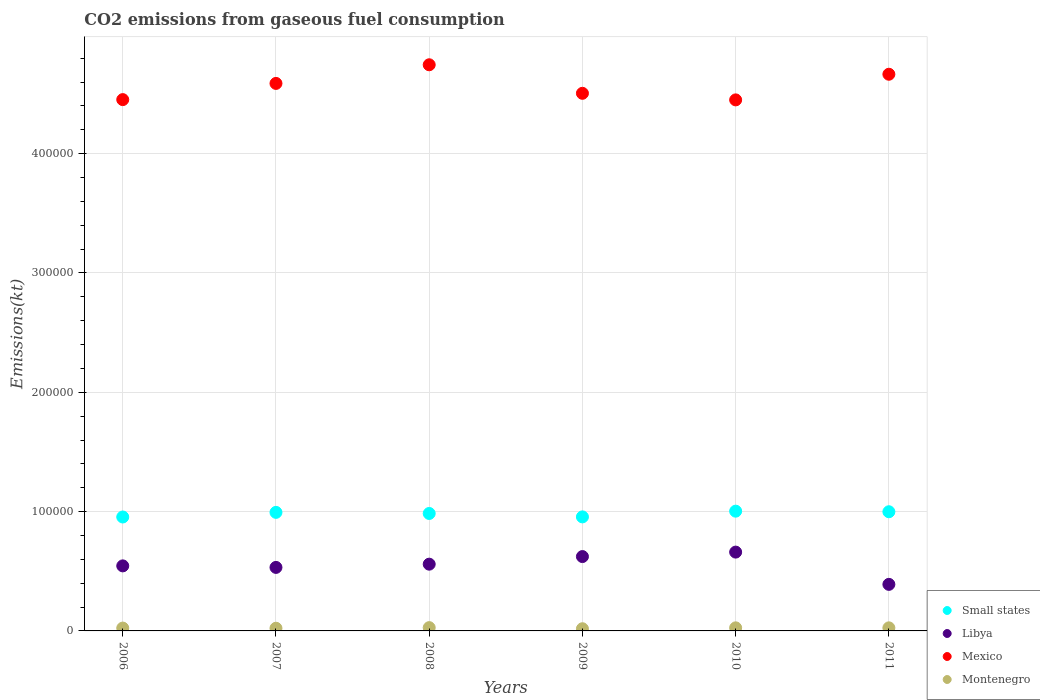How many different coloured dotlines are there?
Ensure brevity in your answer.  4. Is the number of dotlines equal to the number of legend labels?
Ensure brevity in your answer.  Yes. What is the amount of CO2 emitted in Montenegro in 2011?
Your answer should be very brief. 2570.57. Across all years, what is the maximum amount of CO2 emitted in Mexico?
Make the answer very short. 4.74e+05. Across all years, what is the minimum amount of CO2 emitted in Mexico?
Give a very brief answer. 4.45e+05. In which year was the amount of CO2 emitted in Mexico maximum?
Keep it short and to the point. 2008. In which year was the amount of CO2 emitted in Montenegro minimum?
Offer a terse response. 2009. What is the total amount of CO2 emitted in Libya in the graph?
Provide a succinct answer. 3.31e+05. What is the difference between the amount of CO2 emitted in Mexico in 2009 and that in 2011?
Your answer should be very brief. -1.60e+04. What is the difference between the amount of CO2 emitted in Small states in 2006 and the amount of CO2 emitted in Montenegro in 2008?
Offer a very short reply. 9.27e+04. What is the average amount of CO2 emitted in Mexico per year?
Your response must be concise. 4.57e+05. In the year 2007, what is the difference between the amount of CO2 emitted in Small states and amount of CO2 emitted in Libya?
Give a very brief answer. 4.61e+04. What is the ratio of the amount of CO2 emitted in Libya in 2007 to that in 2009?
Your response must be concise. 0.85. Is the amount of CO2 emitted in Mexico in 2008 less than that in 2009?
Keep it short and to the point. No. Is the difference between the amount of CO2 emitted in Small states in 2007 and 2008 greater than the difference between the amount of CO2 emitted in Libya in 2007 and 2008?
Your answer should be very brief. Yes. What is the difference between the highest and the second highest amount of CO2 emitted in Libya?
Offer a terse response. 3740.34. What is the difference between the highest and the lowest amount of CO2 emitted in Small states?
Provide a short and direct response. 4882.64. Is the sum of the amount of CO2 emitted in Small states in 2009 and 2010 greater than the maximum amount of CO2 emitted in Libya across all years?
Provide a succinct answer. Yes. Does the amount of CO2 emitted in Mexico monotonically increase over the years?
Your response must be concise. No. Is the amount of CO2 emitted in Montenegro strictly greater than the amount of CO2 emitted in Libya over the years?
Give a very brief answer. No. Is the amount of CO2 emitted in Small states strictly less than the amount of CO2 emitted in Mexico over the years?
Keep it short and to the point. Yes. How many dotlines are there?
Keep it short and to the point. 4. How many years are there in the graph?
Offer a very short reply. 6. Are the values on the major ticks of Y-axis written in scientific E-notation?
Your answer should be very brief. No. Does the graph contain any zero values?
Your answer should be very brief. No. Does the graph contain grids?
Provide a succinct answer. Yes. How many legend labels are there?
Make the answer very short. 4. How are the legend labels stacked?
Provide a succinct answer. Vertical. What is the title of the graph?
Offer a terse response. CO2 emissions from gaseous fuel consumption. What is the label or title of the Y-axis?
Provide a succinct answer. Emissions(kt). What is the Emissions(kt) in Small states in 2006?
Give a very brief answer. 9.55e+04. What is the Emissions(kt) of Libya in 2006?
Your answer should be compact. 5.45e+04. What is the Emissions(kt) of Mexico in 2006?
Ensure brevity in your answer.  4.45e+05. What is the Emissions(kt) in Montenegro in 2006?
Offer a terse response. 2383.55. What is the Emissions(kt) in Small states in 2007?
Your answer should be compact. 9.94e+04. What is the Emissions(kt) of Libya in 2007?
Keep it short and to the point. 5.32e+04. What is the Emissions(kt) in Mexico in 2007?
Your response must be concise. 4.59e+05. What is the Emissions(kt) of Montenegro in 2007?
Provide a short and direct response. 2251.54. What is the Emissions(kt) in Small states in 2008?
Provide a short and direct response. 9.84e+04. What is the Emissions(kt) of Libya in 2008?
Make the answer very short. 5.59e+04. What is the Emissions(kt) of Mexico in 2008?
Make the answer very short. 4.74e+05. What is the Emissions(kt) in Montenegro in 2008?
Provide a short and direct response. 2750.25. What is the Emissions(kt) of Small states in 2009?
Provide a short and direct response. 9.56e+04. What is the Emissions(kt) of Libya in 2009?
Your answer should be compact. 6.23e+04. What is the Emissions(kt) in Mexico in 2009?
Your response must be concise. 4.51e+05. What is the Emissions(kt) of Montenegro in 2009?
Offer a very short reply. 1826.17. What is the Emissions(kt) in Small states in 2010?
Offer a very short reply. 1.00e+05. What is the Emissions(kt) of Libya in 2010?
Offer a terse response. 6.61e+04. What is the Emissions(kt) of Mexico in 2010?
Provide a short and direct response. 4.45e+05. What is the Emissions(kt) of Montenegro in 2010?
Your response must be concise. 2581.57. What is the Emissions(kt) of Small states in 2011?
Provide a succinct answer. 9.99e+04. What is the Emissions(kt) in Libya in 2011?
Keep it short and to the point. 3.90e+04. What is the Emissions(kt) in Mexico in 2011?
Keep it short and to the point. 4.67e+05. What is the Emissions(kt) of Montenegro in 2011?
Offer a very short reply. 2570.57. Across all years, what is the maximum Emissions(kt) of Small states?
Give a very brief answer. 1.00e+05. Across all years, what is the maximum Emissions(kt) of Libya?
Make the answer very short. 6.61e+04. Across all years, what is the maximum Emissions(kt) of Mexico?
Offer a terse response. 4.74e+05. Across all years, what is the maximum Emissions(kt) in Montenegro?
Keep it short and to the point. 2750.25. Across all years, what is the minimum Emissions(kt) in Small states?
Your response must be concise. 9.55e+04. Across all years, what is the minimum Emissions(kt) of Libya?
Your answer should be compact. 3.90e+04. Across all years, what is the minimum Emissions(kt) of Mexico?
Provide a succinct answer. 4.45e+05. Across all years, what is the minimum Emissions(kt) in Montenegro?
Offer a terse response. 1826.17. What is the total Emissions(kt) of Small states in the graph?
Provide a short and direct response. 5.89e+05. What is the total Emissions(kt) in Libya in the graph?
Keep it short and to the point. 3.31e+05. What is the total Emissions(kt) in Mexico in the graph?
Your answer should be compact. 2.74e+06. What is the total Emissions(kt) in Montenegro in the graph?
Give a very brief answer. 1.44e+04. What is the difference between the Emissions(kt) of Small states in 2006 and that in 2007?
Give a very brief answer. -3870.17. What is the difference between the Emissions(kt) of Libya in 2006 and that in 2007?
Make the answer very short. 1279.78. What is the difference between the Emissions(kt) of Mexico in 2006 and that in 2007?
Provide a succinct answer. -1.36e+04. What is the difference between the Emissions(kt) in Montenegro in 2006 and that in 2007?
Give a very brief answer. 132.01. What is the difference between the Emissions(kt) of Small states in 2006 and that in 2008?
Your response must be concise. -2949.4. What is the difference between the Emissions(kt) of Libya in 2006 and that in 2008?
Keep it short and to the point. -1433.8. What is the difference between the Emissions(kt) in Mexico in 2006 and that in 2008?
Your answer should be compact. -2.92e+04. What is the difference between the Emissions(kt) in Montenegro in 2006 and that in 2008?
Give a very brief answer. -366.7. What is the difference between the Emissions(kt) of Small states in 2006 and that in 2009?
Provide a short and direct response. -88.04. What is the difference between the Emissions(kt) of Libya in 2006 and that in 2009?
Keep it short and to the point. -7807.04. What is the difference between the Emissions(kt) of Mexico in 2006 and that in 2009?
Your answer should be compact. -5284.15. What is the difference between the Emissions(kt) in Montenegro in 2006 and that in 2009?
Make the answer very short. 557.38. What is the difference between the Emissions(kt) in Small states in 2006 and that in 2010?
Your answer should be compact. -4882.64. What is the difference between the Emissions(kt) of Libya in 2006 and that in 2010?
Provide a succinct answer. -1.15e+04. What is the difference between the Emissions(kt) in Mexico in 2006 and that in 2010?
Provide a succinct answer. 227.35. What is the difference between the Emissions(kt) in Montenegro in 2006 and that in 2010?
Offer a terse response. -198.02. What is the difference between the Emissions(kt) in Small states in 2006 and that in 2011?
Your response must be concise. -4398.42. What is the difference between the Emissions(kt) of Libya in 2006 and that in 2011?
Give a very brief answer. 1.55e+04. What is the difference between the Emissions(kt) of Mexico in 2006 and that in 2011?
Ensure brevity in your answer.  -2.13e+04. What is the difference between the Emissions(kt) in Montenegro in 2006 and that in 2011?
Ensure brevity in your answer.  -187.02. What is the difference between the Emissions(kt) in Small states in 2007 and that in 2008?
Offer a very short reply. 920.77. What is the difference between the Emissions(kt) in Libya in 2007 and that in 2008?
Ensure brevity in your answer.  -2713.58. What is the difference between the Emissions(kt) in Mexico in 2007 and that in 2008?
Your answer should be compact. -1.56e+04. What is the difference between the Emissions(kt) of Montenegro in 2007 and that in 2008?
Keep it short and to the point. -498.71. What is the difference between the Emissions(kt) in Small states in 2007 and that in 2009?
Give a very brief answer. 3782.12. What is the difference between the Emissions(kt) of Libya in 2007 and that in 2009?
Keep it short and to the point. -9086.83. What is the difference between the Emissions(kt) in Mexico in 2007 and that in 2009?
Ensure brevity in your answer.  8291.09. What is the difference between the Emissions(kt) of Montenegro in 2007 and that in 2009?
Your response must be concise. 425.37. What is the difference between the Emissions(kt) of Small states in 2007 and that in 2010?
Provide a short and direct response. -1012.48. What is the difference between the Emissions(kt) in Libya in 2007 and that in 2010?
Ensure brevity in your answer.  -1.28e+04. What is the difference between the Emissions(kt) of Mexico in 2007 and that in 2010?
Your answer should be compact. 1.38e+04. What is the difference between the Emissions(kt) of Montenegro in 2007 and that in 2010?
Provide a short and direct response. -330.03. What is the difference between the Emissions(kt) of Small states in 2007 and that in 2011?
Your answer should be very brief. -528.25. What is the difference between the Emissions(kt) in Libya in 2007 and that in 2011?
Make the answer very short. 1.42e+04. What is the difference between the Emissions(kt) of Mexico in 2007 and that in 2011?
Offer a very short reply. -7682.36. What is the difference between the Emissions(kt) in Montenegro in 2007 and that in 2011?
Provide a succinct answer. -319.03. What is the difference between the Emissions(kt) in Small states in 2008 and that in 2009?
Offer a terse response. 2861.35. What is the difference between the Emissions(kt) in Libya in 2008 and that in 2009?
Give a very brief answer. -6373.25. What is the difference between the Emissions(kt) of Mexico in 2008 and that in 2009?
Make the answer very short. 2.39e+04. What is the difference between the Emissions(kt) in Montenegro in 2008 and that in 2009?
Offer a very short reply. 924.08. What is the difference between the Emissions(kt) of Small states in 2008 and that in 2010?
Your response must be concise. -1933.25. What is the difference between the Emissions(kt) of Libya in 2008 and that in 2010?
Provide a short and direct response. -1.01e+04. What is the difference between the Emissions(kt) in Mexico in 2008 and that in 2010?
Ensure brevity in your answer.  2.94e+04. What is the difference between the Emissions(kt) in Montenegro in 2008 and that in 2010?
Offer a very short reply. 168.68. What is the difference between the Emissions(kt) in Small states in 2008 and that in 2011?
Keep it short and to the point. -1449.02. What is the difference between the Emissions(kt) in Libya in 2008 and that in 2011?
Make the answer very short. 1.69e+04. What is the difference between the Emissions(kt) of Mexico in 2008 and that in 2011?
Your response must be concise. 7942.72. What is the difference between the Emissions(kt) of Montenegro in 2008 and that in 2011?
Keep it short and to the point. 179.68. What is the difference between the Emissions(kt) of Small states in 2009 and that in 2010?
Offer a very short reply. -4794.6. What is the difference between the Emissions(kt) in Libya in 2009 and that in 2010?
Your answer should be compact. -3740.34. What is the difference between the Emissions(kt) in Mexico in 2009 and that in 2010?
Keep it short and to the point. 5511.5. What is the difference between the Emissions(kt) in Montenegro in 2009 and that in 2010?
Make the answer very short. -755.4. What is the difference between the Emissions(kt) of Small states in 2009 and that in 2011?
Your answer should be compact. -4310.37. What is the difference between the Emissions(kt) in Libya in 2009 and that in 2011?
Offer a terse response. 2.33e+04. What is the difference between the Emissions(kt) of Mexico in 2009 and that in 2011?
Your answer should be compact. -1.60e+04. What is the difference between the Emissions(kt) in Montenegro in 2009 and that in 2011?
Keep it short and to the point. -744.4. What is the difference between the Emissions(kt) of Small states in 2010 and that in 2011?
Offer a very short reply. 484.23. What is the difference between the Emissions(kt) of Libya in 2010 and that in 2011?
Ensure brevity in your answer.  2.70e+04. What is the difference between the Emissions(kt) in Mexico in 2010 and that in 2011?
Offer a terse response. -2.15e+04. What is the difference between the Emissions(kt) of Montenegro in 2010 and that in 2011?
Keep it short and to the point. 11. What is the difference between the Emissions(kt) of Small states in 2006 and the Emissions(kt) of Libya in 2007?
Offer a very short reply. 4.23e+04. What is the difference between the Emissions(kt) of Small states in 2006 and the Emissions(kt) of Mexico in 2007?
Make the answer very short. -3.63e+05. What is the difference between the Emissions(kt) in Small states in 2006 and the Emissions(kt) in Montenegro in 2007?
Your response must be concise. 9.32e+04. What is the difference between the Emissions(kt) in Libya in 2006 and the Emissions(kt) in Mexico in 2007?
Make the answer very short. -4.04e+05. What is the difference between the Emissions(kt) in Libya in 2006 and the Emissions(kt) in Montenegro in 2007?
Give a very brief answer. 5.23e+04. What is the difference between the Emissions(kt) of Mexico in 2006 and the Emissions(kt) of Montenegro in 2007?
Provide a succinct answer. 4.43e+05. What is the difference between the Emissions(kt) of Small states in 2006 and the Emissions(kt) of Libya in 2008?
Give a very brief answer. 3.95e+04. What is the difference between the Emissions(kt) in Small states in 2006 and the Emissions(kt) in Mexico in 2008?
Ensure brevity in your answer.  -3.79e+05. What is the difference between the Emissions(kt) in Small states in 2006 and the Emissions(kt) in Montenegro in 2008?
Make the answer very short. 9.27e+04. What is the difference between the Emissions(kt) in Libya in 2006 and the Emissions(kt) in Mexico in 2008?
Ensure brevity in your answer.  -4.20e+05. What is the difference between the Emissions(kt) of Libya in 2006 and the Emissions(kt) of Montenegro in 2008?
Provide a succinct answer. 5.18e+04. What is the difference between the Emissions(kt) in Mexico in 2006 and the Emissions(kt) in Montenegro in 2008?
Your response must be concise. 4.43e+05. What is the difference between the Emissions(kt) in Small states in 2006 and the Emissions(kt) in Libya in 2009?
Provide a short and direct response. 3.32e+04. What is the difference between the Emissions(kt) of Small states in 2006 and the Emissions(kt) of Mexico in 2009?
Give a very brief answer. -3.55e+05. What is the difference between the Emissions(kt) in Small states in 2006 and the Emissions(kt) in Montenegro in 2009?
Provide a succinct answer. 9.37e+04. What is the difference between the Emissions(kt) of Libya in 2006 and the Emissions(kt) of Mexico in 2009?
Provide a succinct answer. -3.96e+05. What is the difference between the Emissions(kt) in Libya in 2006 and the Emissions(kt) in Montenegro in 2009?
Keep it short and to the point. 5.27e+04. What is the difference between the Emissions(kt) of Mexico in 2006 and the Emissions(kt) of Montenegro in 2009?
Give a very brief answer. 4.43e+05. What is the difference between the Emissions(kt) of Small states in 2006 and the Emissions(kt) of Libya in 2010?
Your answer should be compact. 2.94e+04. What is the difference between the Emissions(kt) in Small states in 2006 and the Emissions(kt) in Mexico in 2010?
Make the answer very short. -3.50e+05. What is the difference between the Emissions(kt) of Small states in 2006 and the Emissions(kt) of Montenegro in 2010?
Keep it short and to the point. 9.29e+04. What is the difference between the Emissions(kt) of Libya in 2006 and the Emissions(kt) of Mexico in 2010?
Ensure brevity in your answer.  -3.91e+05. What is the difference between the Emissions(kt) of Libya in 2006 and the Emissions(kt) of Montenegro in 2010?
Your response must be concise. 5.19e+04. What is the difference between the Emissions(kt) of Mexico in 2006 and the Emissions(kt) of Montenegro in 2010?
Ensure brevity in your answer.  4.43e+05. What is the difference between the Emissions(kt) in Small states in 2006 and the Emissions(kt) in Libya in 2011?
Your answer should be very brief. 5.65e+04. What is the difference between the Emissions(kt) in Small states in 2006 and the Emissions(kt) in Mexico in 2011?
Offer a very short reply. -3.71e+05. What is the difference between the Emissions(kt) in Small states in 2006 and the Emissions(kt) in Montenegro in 2011?
Provide a short and direct response. 9.29e+04. What is the difference between the Emissions(kt) in Libya in 2006 and the Emissions(kt) in Mexico in 2011?
Offer a terse response. -4.12e+05. What is the difference between the Emissions(kt) in Libya in 2006 and the Emissions(kt) in Montenegro in 2011?
Make the answer very short. 5.19e+04. What is the difference between the Emissions(kt) of Mexico in 2006 and the Emissions(kt) of Montenegro in 2011?
Offer a very short reply. 4.43e+05. What is the difference between the Emissions(kt) in Small states in 2007 and the Emissions(kt) in Libya in 2008?
Your answer should be very brief. 4.34e+04. What is the difference between the Emissions(kt) in Small states in 2007 and the Emissions(kt) in Mexico in 2008?
Provide a short and direct response. -3.75e+05. What is the difference between the Emissions(kt) in Small states in 2007 and the Emissions(kt) in Montenegro in 2008?
Ensure brevity in your answer.  9.66e+04. What is the difference between the Emissions(kt) in Libya in 2007 and the Emissions(kt) in Mexico in 2008?
Give a very brief answer. -4.21e+05. What is the difference between the Emissions(kt) of Libya in 2007 and the Emissions(kt) of Montenegro in 2008?
Your response must be concise. 5.05e+04. What is the difference between the Emissions(kt) of Mexico in 2007 and the Emissions(kt) of Montenegro in 2008?
Your answer should be very brief. 4.56e+05. What is the difference between the Emissions(kt) in Small states in 2007 and the Emissions(kt) in Libya in 2009?
Make the answer very short. 3.70e+04. What is the difference between the Emissions(kt) of Small states in 2007 and the Emissions(kt) of Mexico in 2009?
Offer a very short reply. -3.51e+05. What is the difference between the Emissions(kt) of Small states in 2007 and the Emissions(kt) of Montenegro in 2009?
Keep it short and to the point. 9.75e+04. What is the difference between the Emissions(kt) of Libya in 2007 and the Emissions(kt) of Mexico in 2009?
Keep it short and to the point. -3.97e+05. What is the difference between the Emissions(kt) of Libya in 2007 and the Emissions(kt) of Montenegro in 2009?
Offer a very short reply. 5.14e+04. What is the difference between the Emissions(kt) of Mexico in 2007 and the Emissions(kt) of Montenegro in 2009?
Give a very brief answer. 4.57e+05. What is the difference between the Emissions(kt) in Small states in 2007 and the Emissions(kt) in Libya in 2010?
Provide a short and direct response. 3.33e+04. What is the difference between the Emissions(kt) of Small states in 2007 and the Emissions(kt) of Mexico in 2010?
Keep it short and to the point. -3.46e+05. What is the difference between the Emissions(kt) of Small states in 2007 and the Emissions(kt) of Montenegro in 2010?
Your response must be concise. 9.68e+04. What is the difference between the Emissions(kt) in Libya in 2007 and the Emissions(kt) in Mexico in 2010?
Offer a very short reply. -3.92e+05. What is the difference between the Emissions(kt) in Libya in 2007 and the Emissions(kt) in Montenegro in 2010?
Keep it short and to the point. 5.06e+04. What is the difference between the Emissions(kt) in Mexico in 2007 and the Emissions(kt) in Montenegro in 2010?
Offer a very short reply. 4.56e+05. What is the difference between the Emissions(kt) in Small states in 2007 and the Emissions(kt) in Libya in 2011?
Keep it short and to the point. 6.03e+04. What is the difference between the Emissions(kt) of Small states in 2007 and the Emissions(kt) of Mexico in 2011?
Give a very brief answer. -3.67e+05. What is the difference between the Emissions(kt) in Small states in 2007 and the Emissions(kt) in Montenegro in 2011?
Your answer should be compact. 9.68e+04. What is the difference between the Emissions(kt) in Libya in 2007 and the Emissions(kt) in Mexico in 2011?
Offer a very short reply. -4.13e+05. What is the difference between the Emissions(kt) of Libya in 2007 and the Emissions(kt) of Montenegro in 2011?
Make the answer very short. 5.07e+04. What is the difference between the Emissions(kt) of Mexico in 2007 and the Emissions(kt) of Montenegro in 2011?
Give a very brief answer. 4.56e+05. What is the difference between the Emissions(kt) in Small states in 2008 and the Emissions(kt) in Libya in 2009?
Your answer should be very brief. 3.61e+04. What is the difference between the Emissions(kt) of Small states in 2008 and the Emissions(kt) of Mexico in 2009?
Your answer should be very brief. -3.52e+05. What is the difference between the Emissions(kt) in Small states in 2008 and the Emissions(kt) in Montenegro in 2009?
Provide a succinct answer. 9.66e+04. What is the difference between the Emissions(kt) in Libya in 2008 and the Emissions(kt) in Mexico in 2009?
Provide a succinct answer. -3.95e+05. What is the difference between the Emissions(kt) in Libya in 2008 and the Emissions(kt) in Montenegro in 2009?
Keep it short and to the point. 5.41e+04. What is the difference between the Emissions(kt) of Mexico in 2008 and the Emissions(kt) of Montenegro in 2009?
Your response must be concise. 4.73e+05. What is the difference between the Emissions(kt) in Small states in 2008 and the Emissions(kt) in Libya in 2010?
Your response must be concise. 3.24e+04. What is the difference between the Emissions(kt) in Small states in 2008 and the Emissions(kt) in Mexico in 2010?
Keep it short and to the point. -3.47e+05. What is the difference between the Emissions(kt) in Small states in 2008 and the Emissions(kt) in Montenegro in 2010?
Offer a very short reply. 9.59e+04. What is the difference between the Emissions(kt) of Libya in 2008 and the Emissions(kt) of Mexico in 2010?
Your response must be concise. -3.89e+05. What is the difference between the Emissions(kt) in Libya in 2008 and the Emissions(kt) in Montenegro in 2010?
Keep it short and to the point. 5.34e+04. What is the difference between the Emissions(kt) of Mexico in 2008 and the Emissions(kt) of Montenegro in 2010?
Make the answer very short. 4.72e+05. What is the difference between the Emissions(kt) in Small states in 2008 and the Emissions(kt) in Libya in 2011?
Provide a succinct answer. 5.94e+04. What is the difference between the Emissions(kt) of Small states in 2008 and the Emissions(kt) of Mexico in 2011?
Provide a succinct answer. -3.68e+05. What is the difference between the Emissions(kt) in Small states in 2008 and the Emissions(kt) in Montenegro in 2011?
Offer a very short reply. 9.59e+04. What is the difference between the Emissions(kt) of Libya in 2008 and the Emissions(kt) of Mexico in 2011?
Provide a short and direct response. -4.11e+05. What is the difference between the Emissions(kt) of Libya in 2008 and the Emissions(kt) of Montenegro in 2011?
Provide a short and direct response. 5.34e+04. What is the difference between the Emissions(kt) of Mexico in 2008 and the Emissions(kt) of Montenegro in 2011?
Provide a succinct answer. 4.72e+05. What is the difference between the Emissions(kt) of Small states in 2009 and the Emissions(kt) of Libya in 2010?
Ensure brevity in your answer.  2.95e+04. What is the difference between the Emissions(kt) of Small states in 2009 and the Emissions(kt) of Mexico in 2010?
Your response must be concise. -3.49e+05. What is the difference between the Emissions(kt) in Small states in 2009 and the Emissions(kt) in Montenegro in 2010?
Your answer should be compact. 9.30e+04. What is the difference between the Emissions(kt) in Libya in 2009 and the Emissions(kt) in Mexico in 2010?
Provide a succinct answer. -3.83e+05. What is the difference between the Emissions(kt) in Libya in 2009 and the Emissions(kt) in Montenegro in 2010?
Give a very brief answer. 5.97e+04. What is the difference between the Emissions(kt) of Mexico in 2009 and the Emissions(kt) of Montenegro in 2010?
Your answer should be compact. 4.48e+05. What is the difference between the Emissions(kt) in Small states in 2009 and the Emissions(kt) in Libya in 2011?
Keep it short and to the point. 5.66e+04. What is the difference between the Emissions(kt) of Small states in 2009 and the Emissions(kt) of Mexico in 2011?
Provide a succinct answer. -3.71e+05. What is the difference between the Emissions(kt) of Small states in 2009 and the Emissions(kt) of Montenegro in 2011?
Provide a succinct answer. 9.30e+04. What is the difference between the Emissions(kt) in Libya in 2009 and the Emissions(kt) in Mexico in 2011?
Provide a short and direct response. -4.04e+05. What is the difference between the Emissions(kt) in Libya in 2009 and the Emissions(kt) in Montenegro in 2011?
Offer a very short reply. 5.97e+04. What is the difference between the Emissions(kt) in Mexico in 2009 and the Emissions(kt) in Montenegro in 2011?
Provide a succinct answer. 4.48e+05. What is the difference between the Emissions(kt) of Small states in 2010 and the Emissions(kt) of Libya in 2011?
Keep it short and to the point. 6.13e+04. What is the difference between the Emissions(kt) in Small states in 2010 and the Emissions(kt) in Mexico in 2011?
Keep it short and to the point. -3.66e+05. What is the difference between the Emissions(kt) of Small states in 2010 and the Emissions(kt) of Montenegro in 2011?
Ensure brevity in your answer.  9.78e+04. What is the difference between the Emissions(kt) of Libya in 2010 and the Emissions(kt) of Mexico in 2011?
Offer a very short reply. -4.00e+05. What is the difference between the Emissions(kt) in Libya in 2010 and the Emissions(kt) in Montenegro in 2011?
Offer a very short reply. 6.35e+04. What is the difference between the Emissions(kt) in Mexico in 2010 and the Emissions(kt) in Montenegro in 2011?
Provide a succinct answer. 4.42e+05. What is the average Emissions(kt) in Small states per year?
Keep it short and to the point. 9.82e+04. What is the average Emissions(kt) in Libya per year?
Your response must be concise. 5.52e+04. What is the average Emissions(kt) of Mexico per year?
Keep it short and to the point. 4.57e+05. What is the average Emissions(kt) in Montenegro per year?
Your response must be concise. 2393.94. In the year 2006, what is the difference between the Emissions(kt) of Small states and Emissions(kt) of Libya?
Make the answer very short. 4.10e+04. In the year 2006, what is the difference between the Emissions(kt) in Small states and Emissions(kt) in Mexico?
Offer a very short reply. -3.50e+05. In the year 2006, what is the difference between the Emissions(kt) in Small states and Emissions(kt) in Montenegro?
Offer a terse response. 9.31e+04. In the year 2006, what is the difference between the Emissions(kt) in Libya and Emissions(kt) in Mexico?
Your answer should be very brief. -3.91e+05. In the year 2006, what is the difference between the Emissions(kt) of Libya and Emissions(kt) of Montenegro?
Give a very brief answer. 5.21e+04. In the year 2006, what is the difference between the Emissions(kt) in Mexico and Emissions(kt) in Montenegro?
Ensure brevity in your answer.  4.43e+05. In the year 2007, what is the difference between the Emissions(kt) in Small states and Emissions(kt) in Libya?
Keep it short and to the point. 4.61e+04. In the year 2007, what is the difference between the Emissions(kt) in Small states and Emissions(kt) in Mexico?
Your answer should be compact. -3.60e+05. In the year 2007, what is the difference between the Emissions(kt) in Small states and Emissions(kt) in Montenegro?
Keep it short and to the point. 9.71e+04. In the year 2007, what is the difference between the Emissions(kt) of Libya and Emissions(kt) of Mexico?
Provide a short and direct response. -4.06e+05. In the year 2007, what is the difference between the Emissions(kt) of Libya and Emissions(kt) of Montenegro?
Provide a short and direct response. 5.10e+04. In the year 2007, what is the difference between the Emissions(kt) in Mexico and Emissions(kt) in Montenegro?
Provide a succinct answer. 4.57e+05. In the year 2008, what is the difference between the Emissions(kt) of Small states and Emissions(kt) of Libya?
Your answer should be very brief. 4.25e+04. In the year 2008, what is the difference between the Emissions(kt) in Small states and Emissions(kt) in Mexico?
Provide a short and direct response. -3.76e+05. In the year 2008, what is the difference between the Emissions(kt) in Small states and Emissions(kt) in Montenegro?
Offer a very short reply. 9.57e+04. In the year 2008, what is the difference between the Emissions(kt) in Libya and Emissions(kt) in Mexico?
Offer a very short reply. -4.19e+05. In the year 2008, what is the difference between the Emissions(kt) of Libya and Emissions(kt) of Montenegro?
Ensure brevity in your answer.  5.32e+04. In the year 2008, what is the difference between the Emissions(kt) in Mexico and Emissions(kt) in Montenegro?
Keep it short and to the point. 4.72e+05. In the year 2009, what is the difference between the Emissions(kt) in Small states and Emissions(kt) in Libya?
Make the answer very short. 3.33e+04. In the year 2009, what is the difference between the Emissions(kt) in Small states and Emissions(kt) in Mexico?
Keep it short and to the point. -3.55e+05. In the year 2009, what is the difference between the Emissions(kt) in Small states and Emissions(kt) in Montenegro?
Provide a succinct answer. 9.37e+04. In the year 2009, what is the difference between the Emissions(kt) in Libya and Emissions(kt) in Mexico?
Offer a very short reply. -3.88e+05. In the year 2009, what is the difference between the Emissions(kt) in Libya and Emissions(kt) in Montenegro?
Provide a succinct answer. 6.05e+04. In the year 2009, what is the difference between the Emissions(kt) of Mexico and Emissions(kt) of Montenegro?
Offer a terse response. 4.49e+05. In the year 2010, what is the difference between the Emissions(kt) in Small states and Emissions(kt) in Libya?
Your answer should be compact. 3.43e+04. In the year 2010, what is the difference between the Emissions(kt) in Small states and Emissions(kt) in Mexico?
Provide a short and direct response. -3.45e+05. In the year 2010, what is the difference between the Emissions(kt) of Small states and Emissions(kt) of Montenegro?
Offer a terse response. 9.78e+04. In the year 2010, what is the difference between the Emissions(kt) of Libya and Emissions(kt) of Mexico?
Make the answer very short. -3.79e+05. In the year 2010, what is the difference between the Emissions(kt) of Libya and Emissions(kt) of Montenegro?
Your response must be concise. 6.35e+04. In the year 2010, what is the difference between the Emissions(kt) in Mexico and Emissions(kt) in Montenegro?
Your response must be concise. 4.42e+05. In the year 2011, what is the difference between the Emissions(kt) of Small states and Emissions(kt) of Libya?
Provide a short and direct response. 6.09e+04. In the year 2011, what is the difference between the Emissions(kt) of Small states and Emissions(kt) of Mexico?
Offer a very short reply. -3.67e+05. In the year 2011, what is the difference between the Emissions(kt) of Small states and Emissions(kt) of Montenegro?
Your answer should be compact. 9.73e+04. In the year 2011, what is the difference between the Emissions(kt) in Libya and Emissions(kt) in Mexico?
Give a very brief answer. -4.28e+05. In the year 2011, what is the difference between the Emissions(kt) in Libya and Emissions(kt) in Montenegro?
Provide a short and direct response. 3.64e+04. In the year 2011, what is the difference between the Emissions(kt) of Mexico and Emissions(kt) of Montenegro?
Your answer should be very brief. 4.64e+05. What is the ratio of the Emissions(kt) in Libya in 2006 to that in 2007?
Your answer should be compact. 1.02. What is the ratio of the Emissions(kt) of Mexico in 2006 to that in 2007?
Provide a succinct answer. 0.97. What is the ratio of the Emissions(kt) in Montenegro in 2006 to that in 2007?
Give a very brief answer. 1.06. What is the ratio of the Emissions(kt) in Libya in 2006 to that in 2008?
Your answer should be compact. 0.97. What is the ratio of the Emissions(kt) of Mexico in 2006 to that in 2008?
Provide a succinct answer. 0.94. What is the ratio of the Emissions(kt) in Montenegro in 2006 to that in 2008?
Provide a short and direct response. 0.87. What is the ratio of the Emissions(kt) in Small states in 2006 to that in 2009?
Keep it short and to the point. 1. What is the ratio of the Emissions(kt) of Libya in 2006 to that in 2009?
Give a very brief answer. 0.87. What is the ratio of the Emissions(kt) in Mexico in 2006 to that in 2009?
Make the answer very short. 0.99. What is the ratio of the Emissions(kt) in Montenegro in 2006 to that in 2009?
Your answer should be compact. 1.31. What is the ratio of the Emissions(kt) of Small states in 2006 to that in 2010?
Provide a short and direct response. 0.95. What is the ratio of the Emissions(kt) of Libya in 2006 to that in 2010?
Provide a succinct answer. 0.83. What is the ratio of the Emissions(kt) of Mexico in 2006 to that in 2010?
Offer a terse response. 1. What is the ratio of the Emissions(kt) in Montenegro in 2006 to that in 2010?
Your response must be concise. 0.92. What is the ratio of the Emissions(kt) in Small states in 2006 to that in 2011?
Give a very brief answer. 0.96. What is the ratio of the Emissions(kt) in Libya in 2006 to that in 2011?
Give a very brief answer. 1.4. What is the ratio of the Emissions(kt) of Mexico in 2006 to that in 2011?
Ensure brevity in your answer.  0.95. What is the ratio of the Emissions(kt) in Montenegro in 2006 to that in 2011?
Give a very brief answer. 0.93. What is the ratio of the Emissions(kt) of Small states in 2007 to that in 2008?
Offer a very short reply. 1.01. What is the ratio of the Emissions(kt) of Libya in 2007 to that in 2008?
Keep it short and to the point. 0.95. What is the ratio of the Emissions(kt) in Mexico in 2007 to that in 2008?
Provide a succinct answer. 0.97. What is the ratio of the Emissions(kt) of Montenegro in 2007 to that in 2008?
Ensure brevity in your answer.  0.82. What is the ratio of the Emissions(kt) in Small states in 2007 to that in 2009?
Ensure brevity in your answer.  1.04. What is the ratio of the Emissions(kt) in Libya in 2007 to that in 2009?
Ensure brevity in your answer.  0.85. What is the ratio of the Emissions(kt) of Mexico in 2007 to that in 2009?
Provide a short and direct response. 1.02. What is the ratio of the Emissions(kt) in Montenegro in 2007 to that in 2009?
Your answer should be compact. 1.23. What is the ratio of the Emissions(kt) of Libya in 2007 to that in 2010?
Offer a very short reply. 0.81. What is the ratio of the Emissions(kt) of Mexico in 2007 to that in 2010?
Your response must be concise. 1.03. What is the ratio of the Emissions(kt) of Montenegro in 2007 to that in 2010?
Ensure brevity in your answer.  0.87. What is the ratio of the Emissions(kt) in Libya in 2007 to that in 2011?
Offer a terse response. 1.36. What is the ratio of the Emissions(kt) of Mexico in 2007 to that in 2011?
Keep it short and to the point. 0.98. What is the ratio of the Emissions(kt) in Montenegro in 2007 to that in 2011?
Ensure brevity in your answer.  0.88. What is the ratio of the Emissions(kt) of Small states in 2008 to that in 2009?
Your answer should be very brief. 1.03. What is the ratio of the Emissions(kt) of Libya in 2008 to that in 2009?
Ensure brevity in your answer.  0.9. What is the ratio of the Emissions(kt) of Mexico in 2008 to that in 2009?
Offer a very short reply. 1.05. What is the ratio of the Emissions(kt) in Montenegro in 2008 to that in 2009?
Your response must be concise. 1.51. What is the ratio of the Emissions(kt) of Small states in 2008 to that in 2010?
Ensure brevity in your answer.  0.98. What is the ratio of the Emissions(kt) of Libya in 2008 to that in 2010?
Make the answer very short. 0.85. What is the ratio of the Emissions(kt) in Mexico in 2008 to that in 2010?
Your answer should be compact. 1.07. What is the ratio of the Emissions(kt) in Montenegro in 2008 to that in 2010?
Make the answer very short. 1.07. What is the ratio of the Emissions(kt) of Small states in 2008 to that in 2011?
Provide a short and direct response. 0.99. What is the ratio of the Emissions(kt) of Libya in 2008 to that in 2011?
Your response must be concise. 1.43. What is the ratio of the Emissions(kt) in Mexico in 2008 to that in 2011?
Your answer should be very brief. 1.02. What is the ratio of the Emissions(kt) of Montenegro in 2008 to that in 2011?
Offer a terse response. 1.07. What is the ratio of the Emissions(kt) in Small states in 2009 to that in 2010?
Offer a terse response. 0.95. What is the ratio of the Emissions(kt) of Libya in 2009 to that in 2010?
Make the answer very short. 0.94. What is the ratio of the Emissions(kt) of Mexico in 2009 to that in 2010?
Keep it short and to the point. 1.01. What is the ratio of the Emissions(kt) of Montenegro in 2009 to that in 2010?
Provide a short and direct response. 0.71. What is the ratio of the Emissions(kt) of Small states in 2009 to that in 2011?
Offer a terse response. 0.96. What is the ratio of the Emissions(kt) in Libya in 2009 to that in 2011?
Your answer should be very brief. 1.6. What is the ratio of the Emissions(kt) in Mexico in 2009 to that in 2011?
Your answer should be compact. 0.97. What is the ratio of the Emissions(kt) of Montenegro in 2009 to that in 2011?
Give a very brief answer. 0.71. What is the ratio of the Emissions(kt) of Small states in 2010 to that in 2011?
Keep it short and to the point. 1. What is the ratio of the Emissions(kt) in Libya in 2010 to that in 2011?
Give a very brief answer. 1.69. What is the ratio of the Emissions(kt) of Mexico in 2010 to that in 2011?
Offer a terse response. 0.95. What is the difference between the highest and the second highest Emissions(kt) in Small states?
Provide a short and direct response. 484.23. What is the difference between the highest and the second highest Emissions(kt) of Libya?
Provide a short and direct response. 3740.34. What is the difference between the highest and the second highest Emissions(kt) in Mexico?
Make the answer very short. 7942.72. What is the difference between the highest and the second highest Emissions(kt) in Montenegro?
Your answer should be compact. 168.68. What is the difference between the highest and the lowest Emissions(kt) in Small states?
Keep it short and to the point. 4882.64. What is the difference between the highest and the lowest Emissions(kt) of Libya?
Give a very brief answer. 2.70e+04. What is the difference between the highest and the lowest Emissions(kt) of Mexico?
Keep it short and to the point. 2.94e+04. What is the difference between the highest and the lowest Emissions(kt) of Montenegro?
Your answer should be very brief. 924.08. 